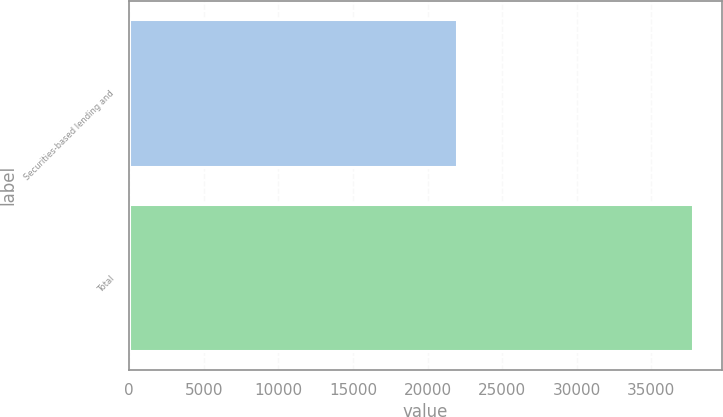Convert chart to OTSL. <chart><loc_0><loc_0><loc_500><loc_500><bar_chart><fcel>Securities-based lending and<fcel>Total<nl><fcel>21997<fcel>37822<nl></chart> 